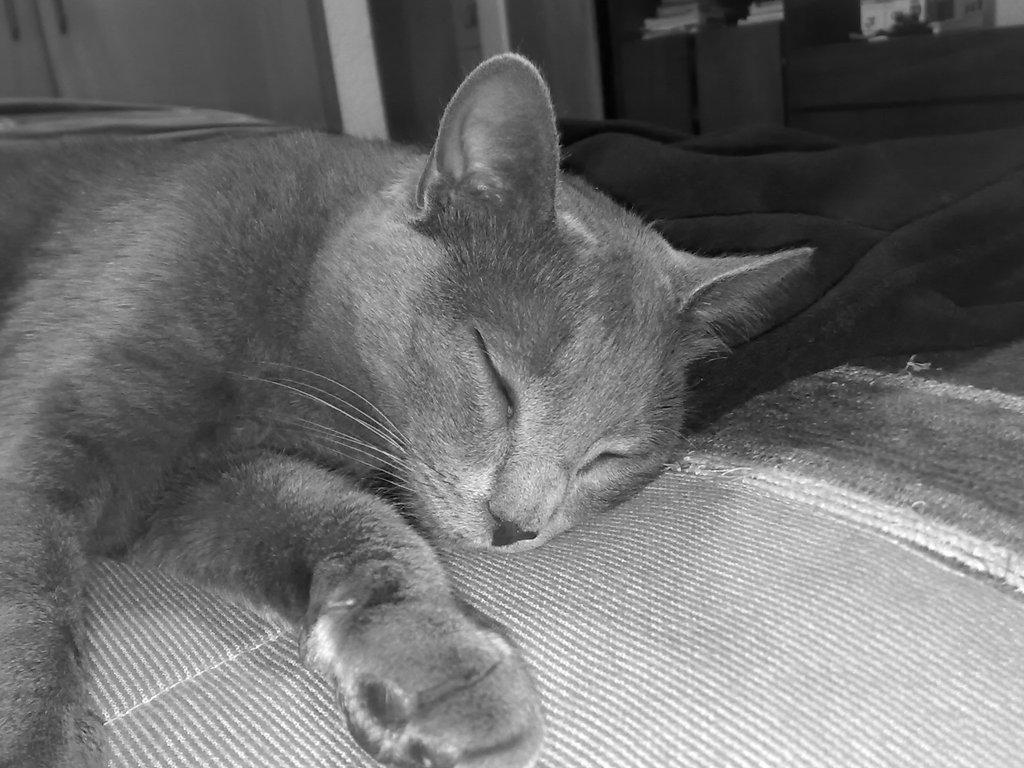What is the color scheme of the image? The image is black and white. What animal can be seen in the image? There is a cat in the image. What is the cat doing in the image? The cat is lying on a surface. What type of furniture is visible in the background of the image? There is a sofa in the background of the image. What other objects can be seen in the background of the image? There are other unspecified objects in the background of the image. What type of linen is being used to dry the cat in the image? There is no linen or any indication of drying the cat in the image. 